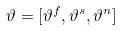Convert formula to latex. <formula><loc_0><loc_0><loc_500><loc_500>\vartheta = [ \vartheta ^ { f } , \vartheta ^ { s } , \vartheta ^ { n } ]</formula> 